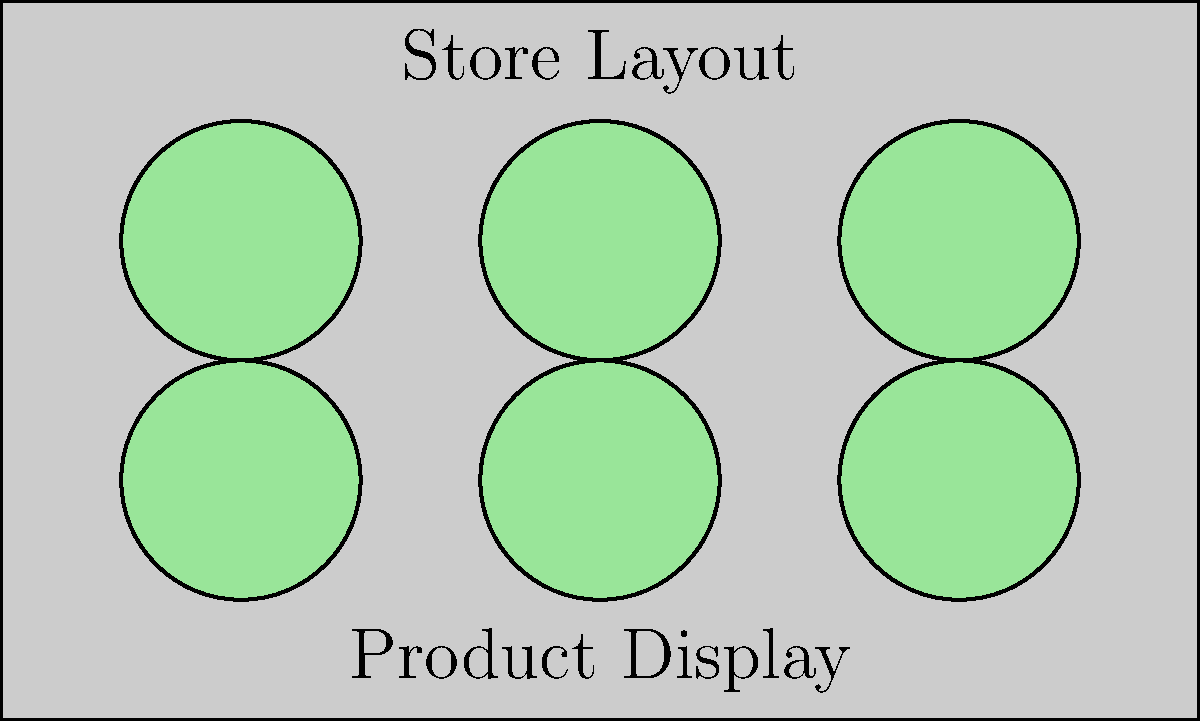In a rectangular store layout measuring 10 units by 6 units, circular product displays with a radius of 1 unit are arranged as shown in the diagram. What is the maximum number of additional circular displays with the same radius that can be added without overlapping existing displays or exceeding the store boundaries? To solve this problem, we'll follow these steps:

1) First, observe the current arrangement:
   - The store is 10 units wide and 6 units tall
   - There are 6 circular displays, each with a radius of 1 unit
   - The displays are arranged in a 3x2 grid

2) To maximize the number of additional displays, we need to find the gaps:
   - Between displays horizontally: There are 2 gaps of 2 units each (10 - 3*2 = 4, divided by 2)
   - Between displays vertically: There is 1 gap of 2 units (6 - 2*2 = 2)
   - Along the edges: 1 unit gap on all sides

3) In the horizontal gaps:
   - Each gap is 2 units wide, which is exactly enough for one display (diameter = 2 units)
   - We can fit 2 new displays (1 in each gap)

4) In the vertical gap:
   - The gap is 2 units tall, enough for one display
   - We can fit 3 new displays in this row (including the horizontal gaps)

5) Along the edges:
   - Top edge: We can fit 3 displays in the 1-unit gap (at x = 2, 5, and 8)
   - Bottom edge: We can fit 3 displays similarly
   - Left and right edges: We can fit 1 display on each side (at y = 3)

6) Summing up the additional displays:
   - Horizontal gaps: 2
   - Vertical gap: 3
   - Top edge: 3
   - Bottom edge: 3
   - Left edge: 1
   - Right edge: 1

Total additional displays: 2 + 3 + 3 + 3 + 1 + 1 = 13
Answer: 13 displays 